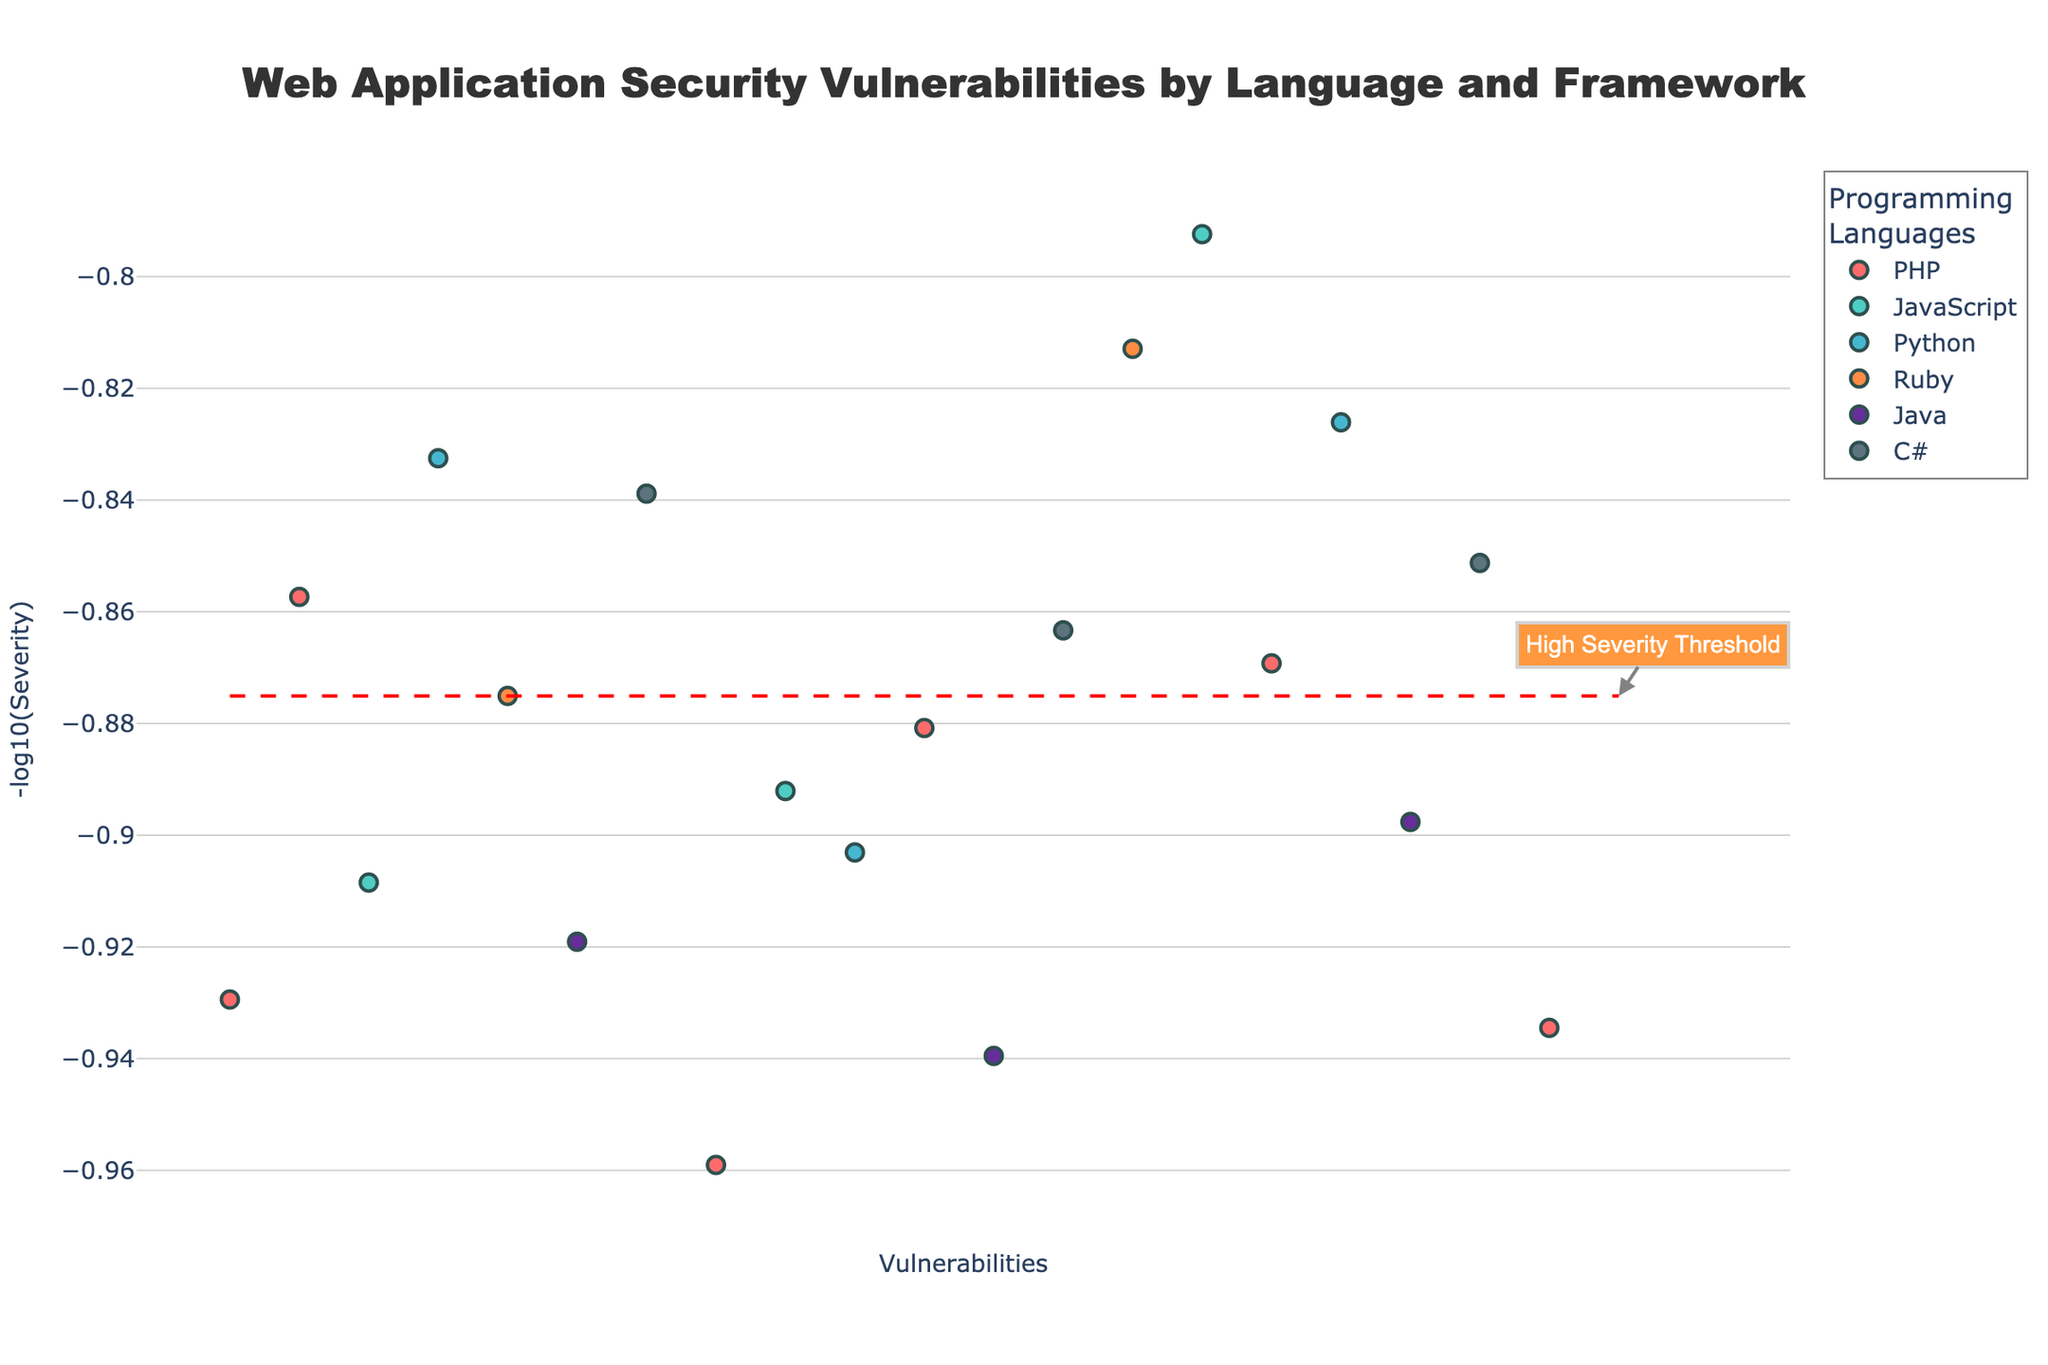What is the title of the figure? The title of the figure can usually be found at the top and is meant to describe what the plot represents. In this case, it is clearly shown at the center-top of the plot.
Answer: Web Application Security Vulnerabilities by Language and Framework How many programming languages are represented in the plot? By counting the number of unique colors in the legend or the number of unique language names provided in the legend, we can determine how many programming languages are represented.
Answer: 6 Which language has the highest severity vulnerability, and what is the severity? This involves finding the highest point on the Y-axis, then matching it to the corresponding language and severity value as shown in the hover text or by color on the plot.
Answer: PHP with severity 9.1 What is the purpose of the red dashed line in the plot? The red dashed line is an additional visual guide to indicate a threshold value, which is labelled as the "High Severity Threshold."
Answer: It indicates the High Severity Threshold What data point represents a Security Misconfiguration vulnerability and which language does it pertain to? By looking at the hover text, we can search for "Security Misconfiguration" and identify the language associated with it.
Answer: Python (Django) Are there any vulnerabilities above the high severity threshold for Java? If so, how many? We identify points related to Java by their color and check if they are above the red dashed line. Counting these points gives the answer.
Answer: 2 Which languages have vulnerabilities below the high severity threshold? Assess the points on the plot for each language and see which ones fall below the red dashed line.
Answer: Python, Ruby, C#, JavaScript, PHP Compare the highest severity vulnerabilities for Java and PHP. Which is higher and by how much? Find the highest severity for both Java and PHP from the plot and subtract the lower from the higher value. Java's highest severity is 8.7, and PHP's is 9.1.
Answer: PHP by 0.4 How many vulnerabilities does the CodeIgniter framework have? Count the number of points in the plot with hover text that mentions the CodeIgniter framework.
Answer: 3 Out of the detected vulnerabilities, which framework has the highest severity value, and what kind of vulnerability is it? Identify the framework by reviewing the hover text and comparing severity values to determine which is the highest.
Answer: CodeIgniter with Remote Code Execution 